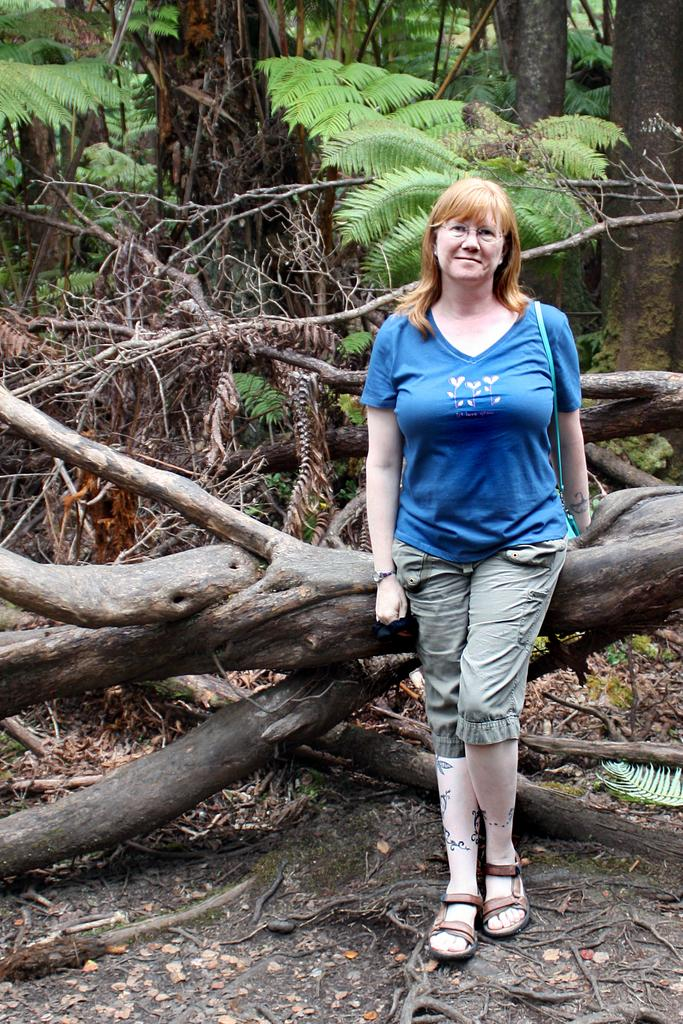Who is the main subject in the image? There is a woman in the image. What is the woman standing in front of? The woman is standing in front of a log of a tree. What can be seen in the background of the image? There are dry trees and plants in the background of the image. What type of brake can be seen on the woman's shoes in the image? There is no brake visible on the woman's shoes in the image. What drink is the woman holding in the image? There is no drink visible in the woman's hand or anywhere in the image. 